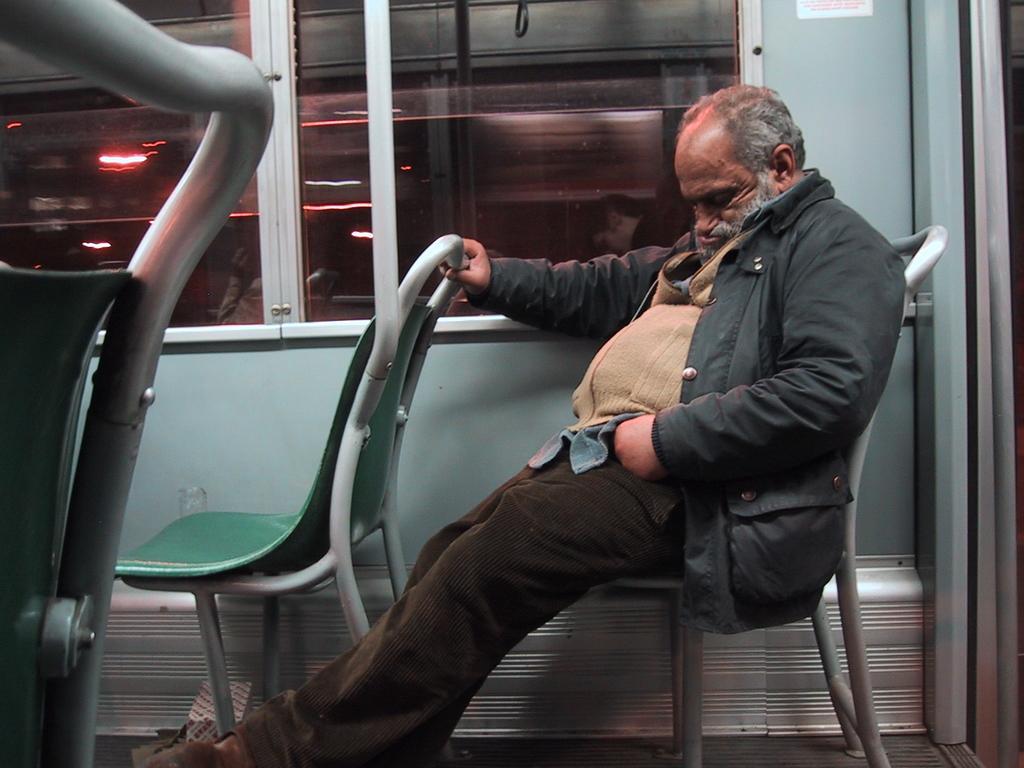Could you give a brief overview of what you see in this image? This is a picture of a man sitting on a chair. This is the inside view of a vehicle the man is sitting behind the glass window. 